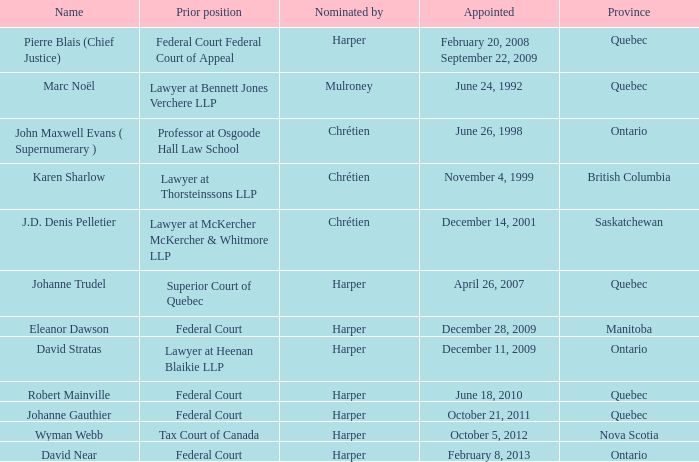What was the prior position held by Wyman Webb? Tax Court of Canada. 